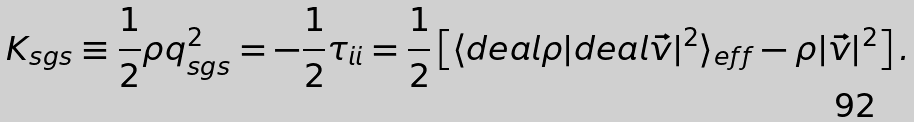<formula> <loc_0><loc_0><loc_500><loc_500>K _ { s g s } \equiv \frac { 1 } { 2 } \rho q _ { s g s } ^ { 2 } = - \frac { 1 } { 2 } \tau _ { i i } = \frac { 1 } { 2 } \left [ \langle \i d e a l { \rho } | \i d e a l { \vec { v } } | ^ { 2 } \rangle _ { e f f } - \rho | \vec { v } | ^ { 2 } \right ] .</formula> 